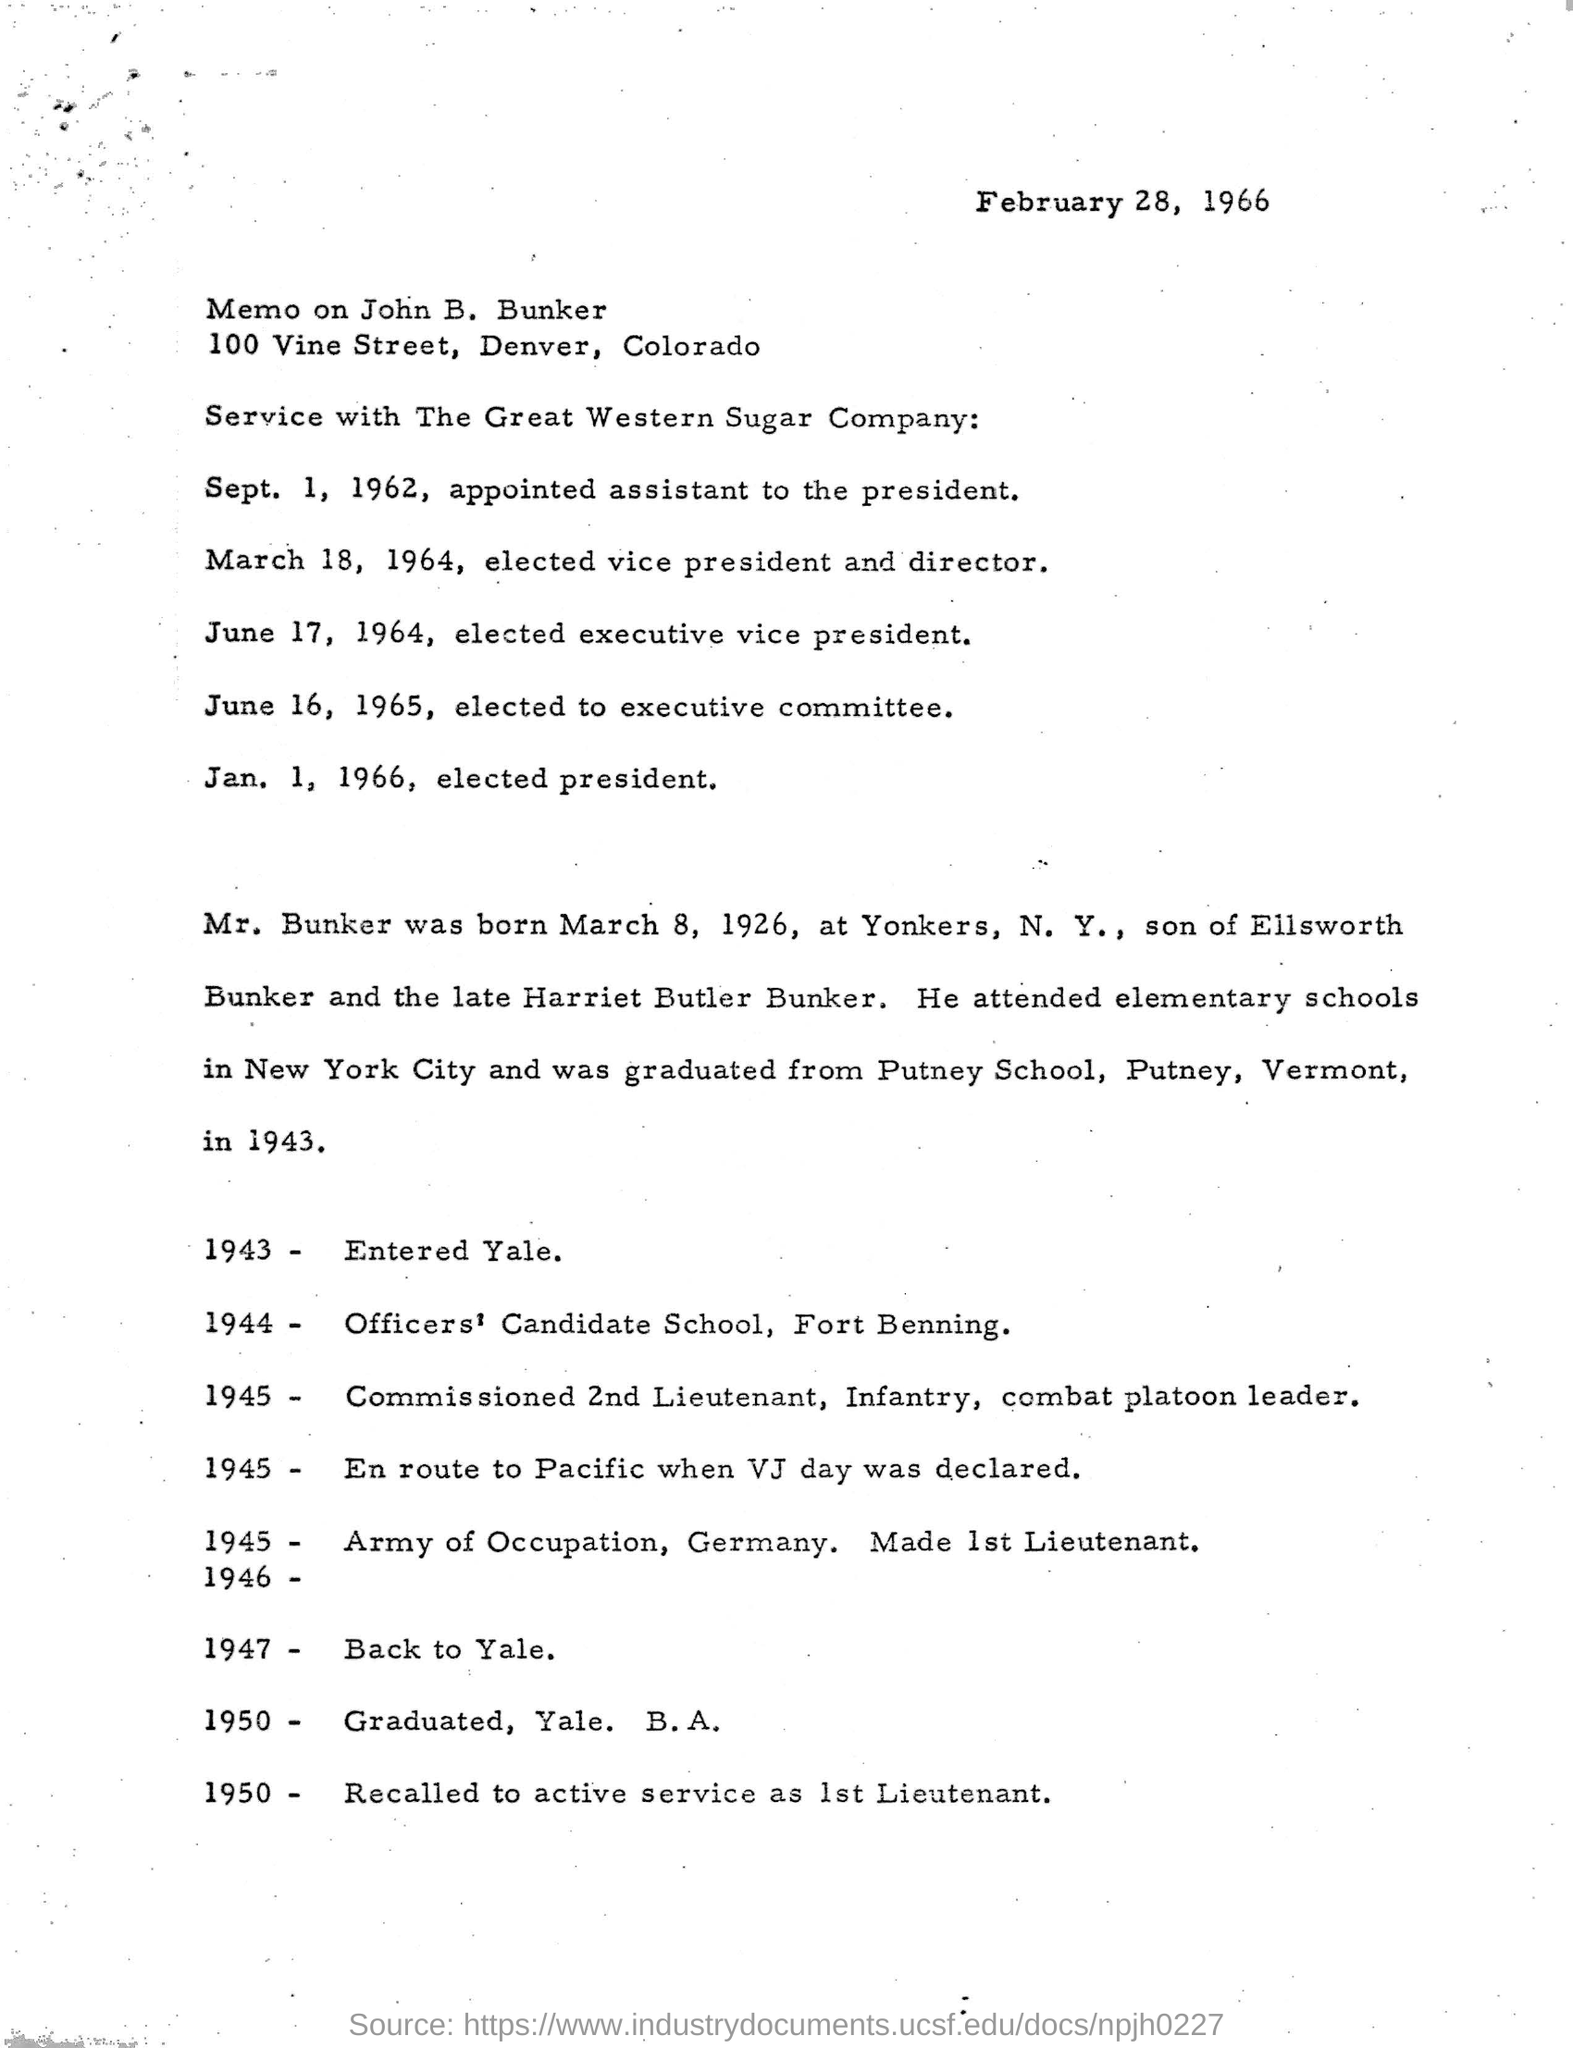Whose memo mentioned in the document ?
Your answer should be very brief. John b. bunker. What is the address of the john b. bunker?
Your answer should be compact. 100 Vine Street, Denver, Colorado. When did mr. bunker was born?
Your answer should be very brief. March 8, 1926,. Who are the parents for john B.bunker?
Make the answer very short. Ellsworth Bunker and the late Harriet Butler Bunker. In which city  john b.bunker attended for elementary?
Provide a succinct answer. New York City. When did he graduated from putney school?
Your response must be concise. 1943. In which year he joined for the officers candidate school, fort benning?
Ensure brevity in your answer.  1944. When joined in army of occupation in 1945 for which post he is designated?
Provide a short and direct response. Made 1st Lieutenant. When he is elected as vice president and director?
Provide a short and direct response. March 18, 1964,. When did  john b.bunker was elected president for the great western sugar company ?
Keep it short and to the point. Jan. 1, 1966,. 